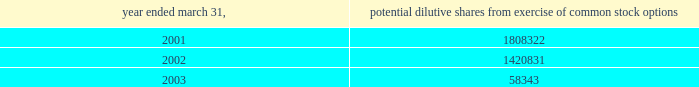( i ) intellectual property the company capitalizes as intellectual property costs incurred , excluding costs associated with company personnel , relating to patenting its technology .
Capitalized costs , the majority of which represent legal costs , reflect the cost of both awarded patents and patents pending .
The company amortizes the cost of these patents on a straight-line basis over a period of seven years .
If the company elects to stop pursuing a particular patent application or determines that a patent application is not likely to be awarded for a particular patent or elects to discontinue payment of required maintenance fees for a particular patent , the company at that time records as expense the net capitalized amount of such patent application or patent .
The company does not capitalize maintenance fees for patents .
( j ) net loss per share basic net loss per share is computed by dividing net loss by the weighted-average number of common shares outstanding during the fiscal year .
Diluted net loss per share is computed by dividing net loss by the weighted-average number of dilutive common shares outstanding during the fiscal year .
Diluted weighted-average shares reflect the dilutive effect , if any , of potential common stock such as options and warrants based on the treasury stock method .
No potential common stock is considered dilutive in periods in which a loss is reported , such as the fiscal years ended march 31 , 2001 , 2002 and 2003 , because all such common equivalent shares would be antidilutive .
The calculation of diluted weighted-average shares outstanding for the years ended march 31 , 2001 , 2002 and 2003 excludes the options to purchase common stock as shown below .
Potential dilutive shares year ended march 31 , from exercise of common stock options .
The calculation of diluted weighted-average shares outstanding excludes unissued shares of common stock associated with outstanding stock options that have exercise prices greater than the average market price of abiomed common stock during the period .
For the fiscal years ending march 31 , 2001 , 2002 and 2003 , the weighted-average number of these potential shares totaled 61661 , 341495 and 2463715 shares , respectively .
The calculation of diluted weighted-average shares outstanding for the years ended march 31 , 2001 , 2002 and 2003 also excludes warrants to purchase 400000 shares of common stock issued in connection with the acquisition of intellectual property ( see note 4 ) .
( k ) cash and cash equivalents the company classifies any marketable security with a maturity date of 90 days or less at the time of purchase as a cash equivalent .
( l ) marketable securities the company classifies any security with a maturity date of greater than 90 days at the time of purchase as marketable securities and classifies marketable securities with a maturity date of greater than one year from the balance sheet date as long-term investments .
Under statement of financial accounting standards ( sfas ) no .
115 , accounting for certain investments in debt and equity securities , securities that the company has the positive intent and ability to hold to maturity are reported at amortized cost and classified as held-to-maturity securities .
The amortized cost and market value of marketable securities were approximately $ 25654000 and $ 25661000 at march 31 , 2002 , and $ 9877000 and $ 9858000 at march 31 , 2003 , respectively .
At march 31 , 2003 , these short-term investments consisted primarily of government securities .
( m ) disclosures about fair value of financial instruments as of march 31 , 2002 and 2003 , the company 2019s financial instruments were comprised of cash and cash equivalents , marketable securities , accounts receivable and accounts payable , the carrying amounts of which approximated fair market value .
( n ) comprehensive income sfas no .
130 , reporting comprehensive income , requires disclosure of all components of comprehensive income and loss on an annual and interim basis .
Comprehensive income and loss is defined as the change in equity of a business enterprise during a period from transactions and other events and circumstances from non-owner sources .
Other than the reported net loss , there were no components of comprehensive income or loss which require disclosure for the years ended march 31 , 2001 , 2002 and 2003 .
Notes to consolidated financial statements ( continued ) march 31 , 2003 page 20 .
What is the difference in market value of marketable securities between 2002 and 2003? 
Computations: (9858000 - 25661000)
Answer: -15803000.0. 